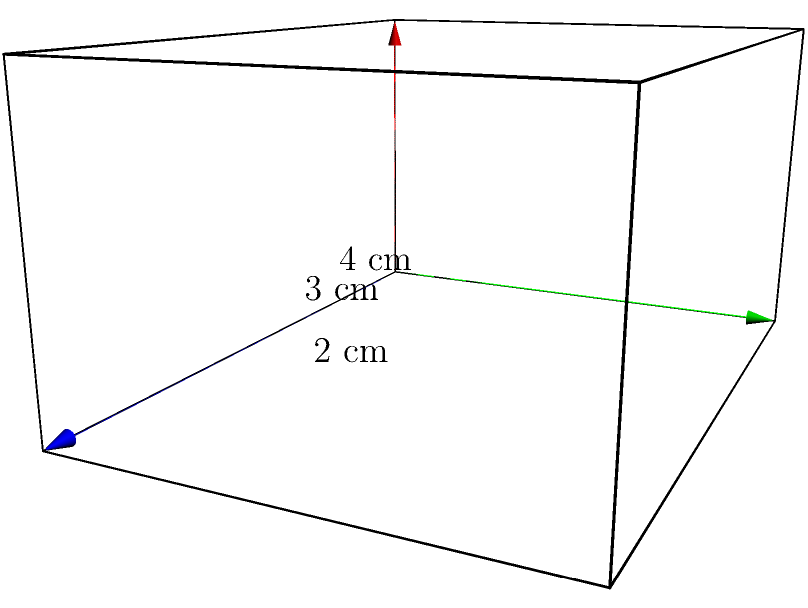Calculate the surface area of the rectangular prism shown in the diagram. All measurements are in centimeters. To calculate the surface area of a rectangular prism, we need to find the area of all six faces and add them together. Let's break it down step-by-step:

1. Identify the dimensions:
   Length (l) = 4 cm
   Width (w) = 3 cm
   Height (h) = 2 cm

2. Calculate the areas of each pair of faces:
   - Front and back faces: $A_1 = 2(l \times h) = 2(4 \times 2) = 16$ cm²
   - Left and right faces: $A_2 = 2(w \times h) = 2(3 \times 2) = 12$ cm²
   - Top and bottom faces: $A_3 = 2(l \times w) = 2(4 \times 3) = 24$ cm²

3. Sum up all the areas:
   Total Surface Area = $A_1 + A_2 + A_3$
   $$ \text{Surface Area} = 16 + 12 + 24 = 52 \text{ cm²} $$

Therefore, the total surface area of the rectangular prism is 52 square centimeters.
Answer: 52 cm² 